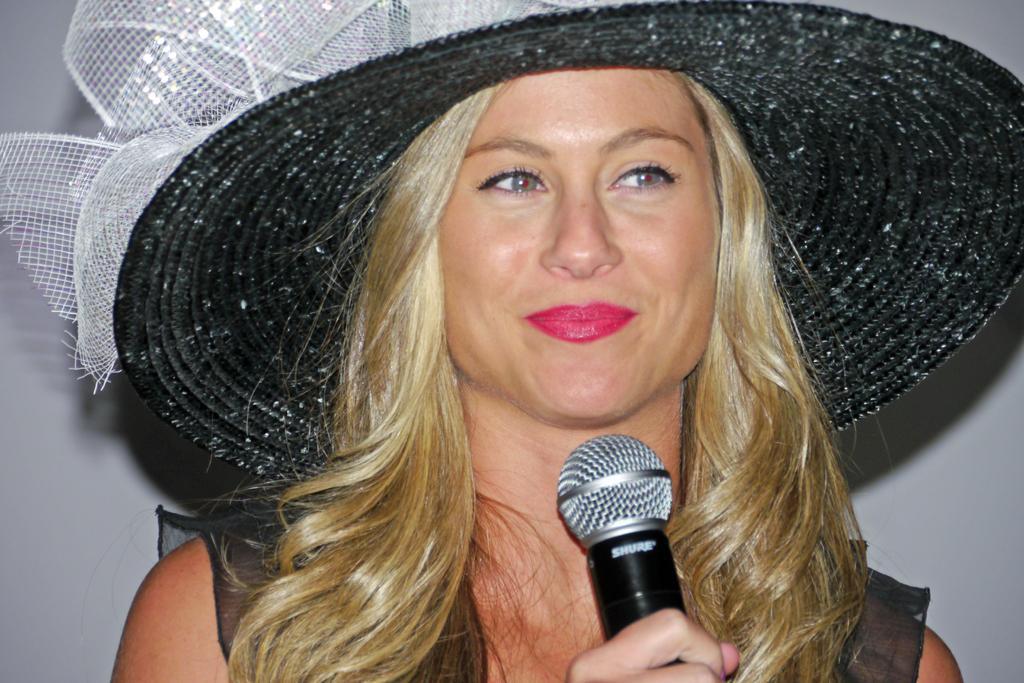In one or two sentences, can you explain what this image depicts? In the image there is a woman wearing a hat which is in black color holding a microphone and she is also having smile on her lips. 